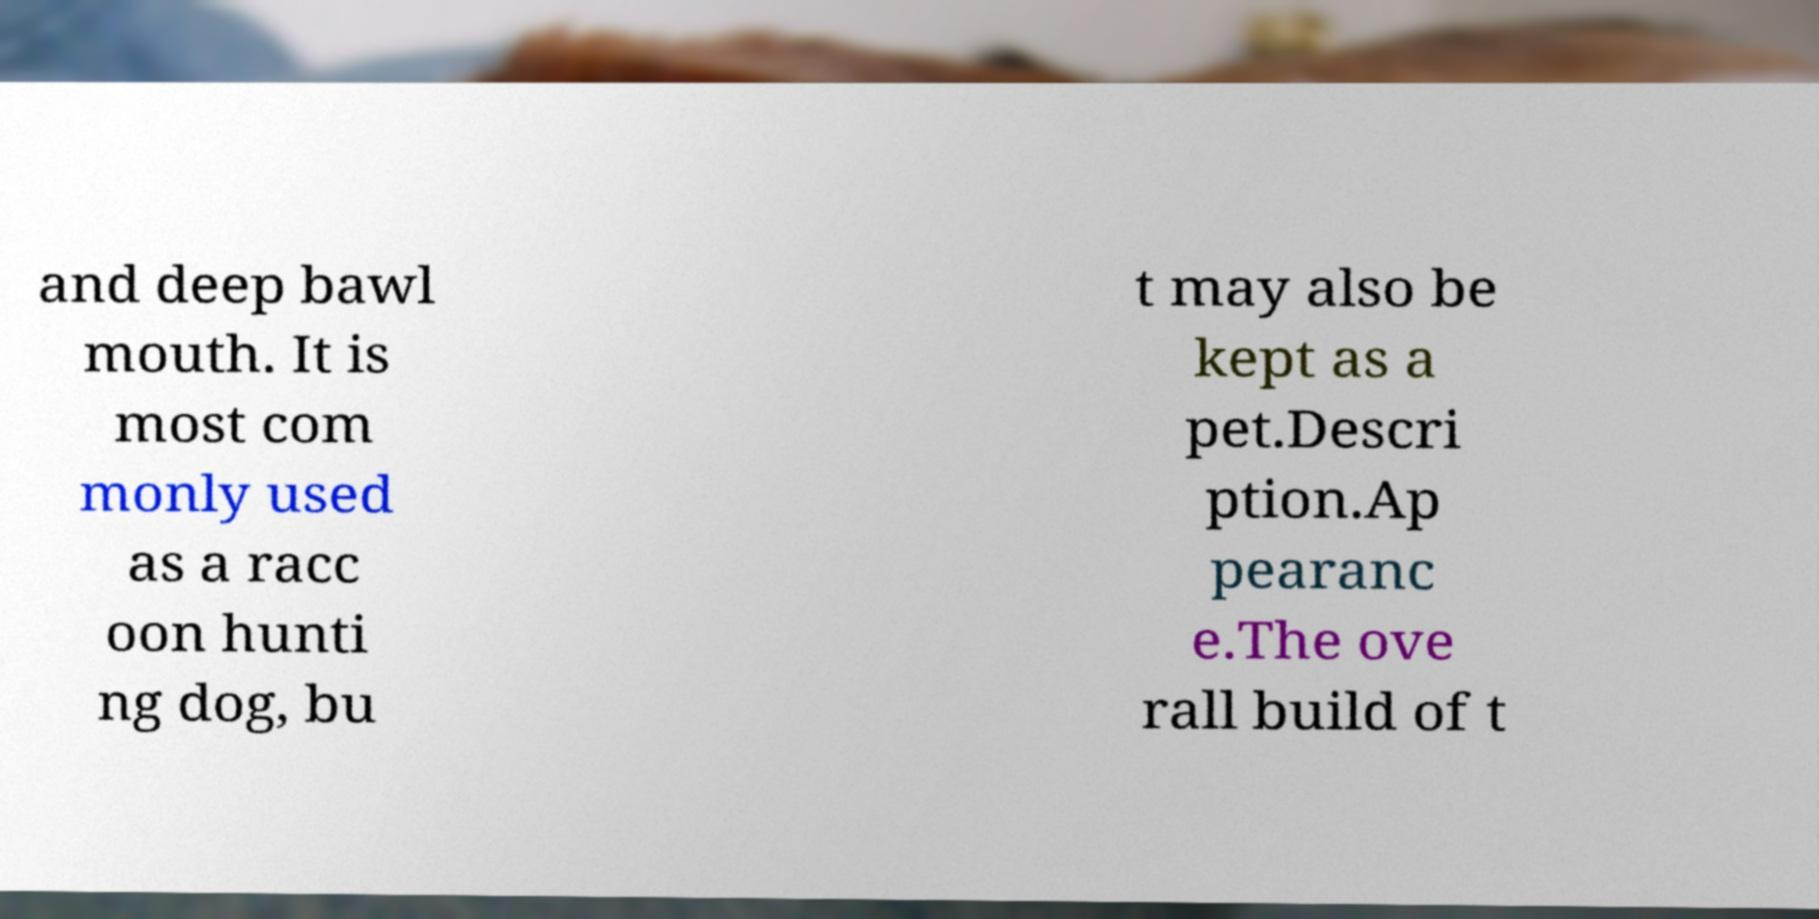For documentation purposes, I need the text within this image transcribed. Could you provide that? and deep bawl mouth. It is most com monly used as a racc oon hunti ng dog, bu t may also be kept as a pet.Descri ption.Ap pearanc e.The ove rall build of t 